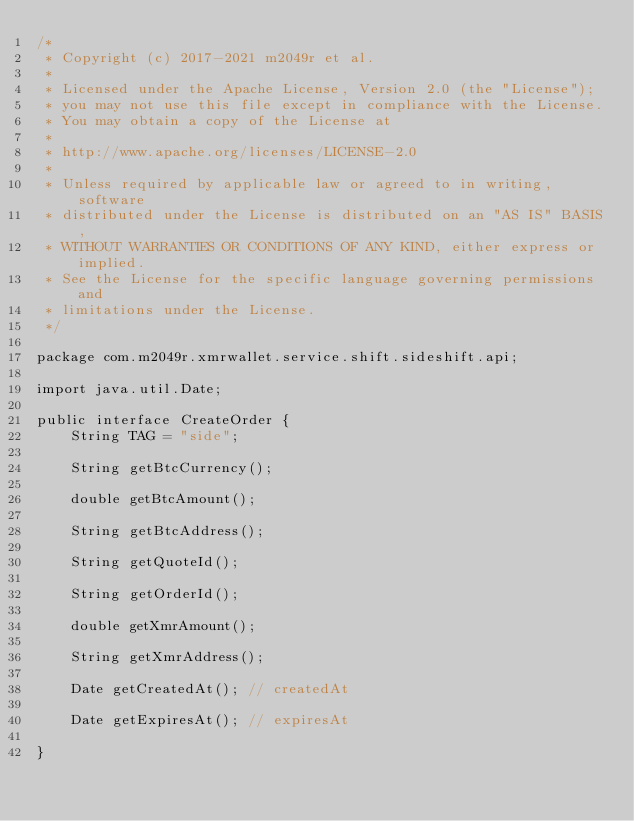Convert code to text. <code><loc_0><loc_0><loc_500><loc_500><_Java_>/*
 * Copyright (c) 2017-2021 m2049r et al.
 *
 * Licensed under the Apache License, Version 2.0 (the "License");
 * you may not use this file except in compliance with the License.
 * You may obtain a copy of the License at
 *
 * http://www.apache.org/licenses/LICENSE-2.0
 *
 * Unless required by applicable law or agreed to in writing, software
 * distributed under the License is distributed on an "AS IS" BASIS,
 * WITHOUT WARRANTIES OR CONDITIONS OF ANY KIND, either express or implied.
 * See the License for the specific language governing permissions and
 * limitations under the License.
 */

package com.m2049r.xmrwallet.service.shift.sideshift.api;

import java.util.Date;

public interface CreateOrder {
    String TAG = "side";

    String getBtcCurrency();

    double getBtcAmount();

    String getBtcAddress();

    String getQuoteId();

    String getOrderId();

    double getXmrAmount();

    String getXmrAddress();

    Date getCreatedAt(); // createdAt

    Date getExpiresAt(); // expiresAt

}
</code> 